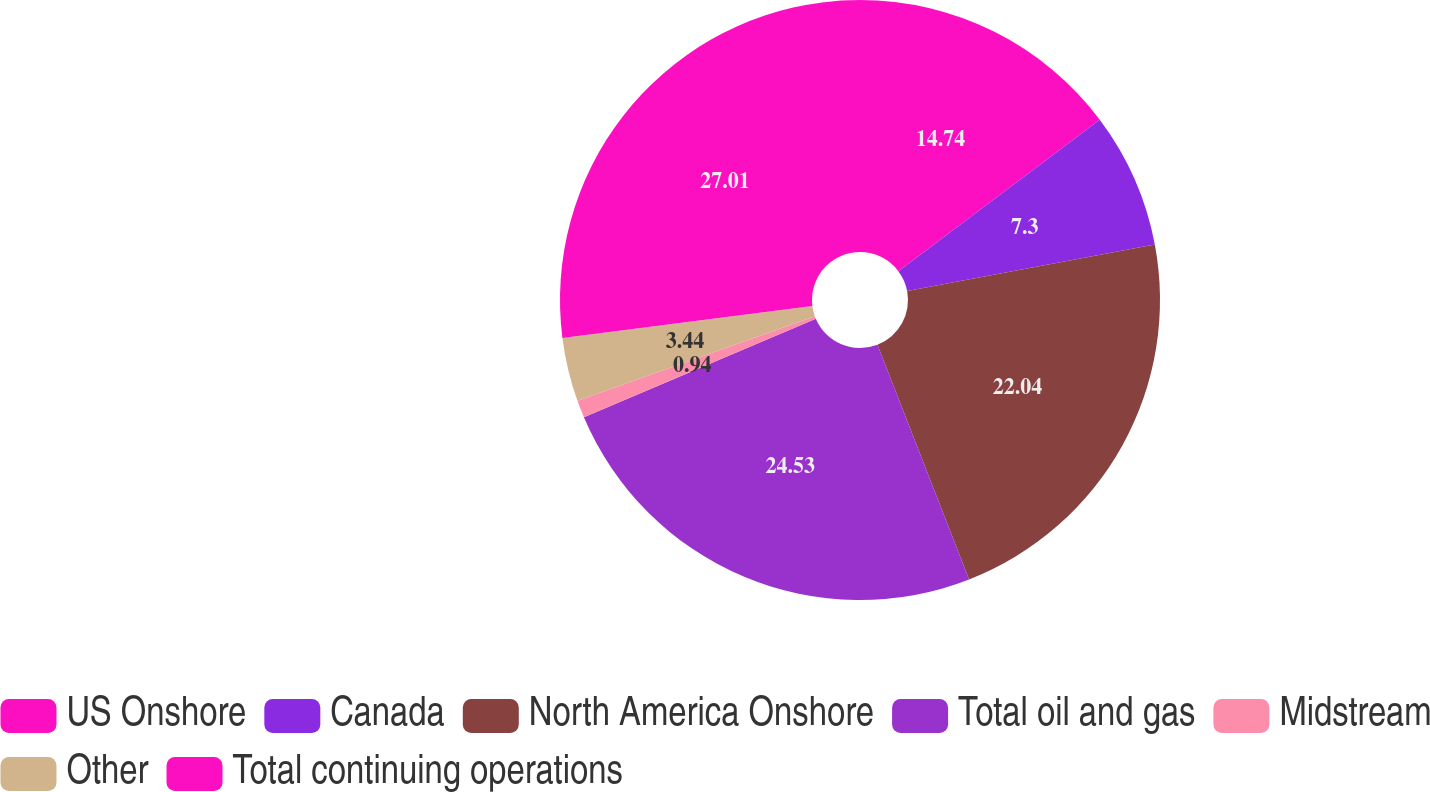<chart> <loc_0><loc_0><loc_500><loc_500><pie_chart><fcel>US Onshore<fcel>Canada<fcel>North America Onshore<fcel>Total oil and gas<fcel>Midstream<fcel>Other<fcel>Total continuing operations<nl><fcel>14.74%<fcel>7.3%<fcel>22.04%<fcel>24.53%<fcel>0.94%<fcel>3.44%<fcel>27.02%<nl></chart> 